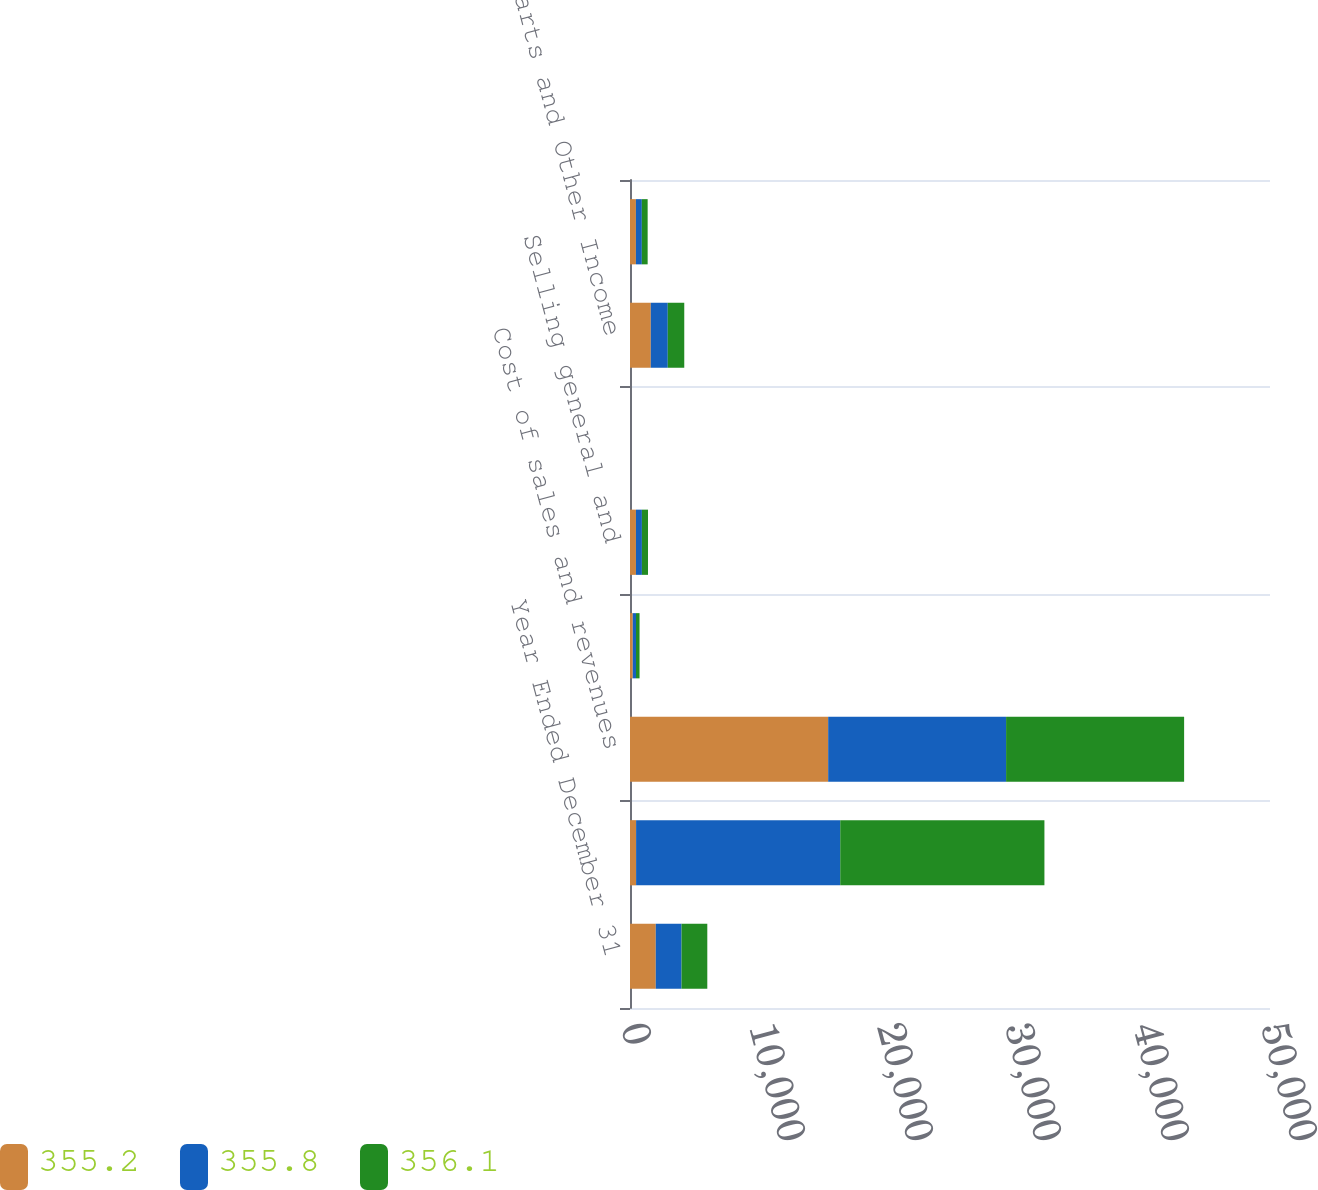Convert chart. <chart><loc_0><loc_0><loc_500><loc_500><stacked_bar_chart><ecel><fcel>Year Ended December 31<fcel>Net sales and revenues<fcel>Cost of sales and revenues<fcel>Research and development<fcel>Selling general and<fcel>Interest and other expense<fcel>Truck Parts and Other Income<fcel>Interest and fees<nl><fcel>355.2<fcel>2014<fcel>476.4<fcel>15481.6<fcel>215.6<fcel>465.2<fcel>5.5<fcel>1624.9<fcel>462.6<nl><fcel>355.8<fcel>2013<fcel>15948.9<fcel>13900.7<fcel>251.4<fcel>465.3<fcel>5.3<fcel>1326.2<fcel>462.8<nl><fcel>356.1<fcel>2012<fcel>15951.7<fcel>13908.3<fcel>279.3<fcel>476.4<fcel>0.3<fcel>1288<fcel>453.7<nl></chart> 